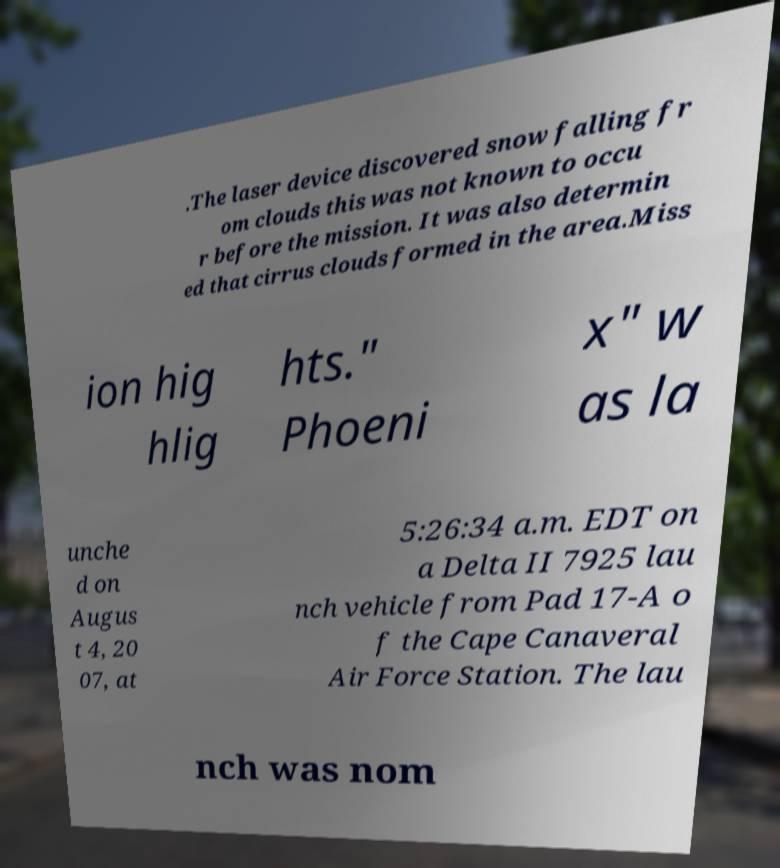Can you accurately transcribe the text from the provided image for me? .The laser device discovered snow falling fr om clouds this was not known to occu r before the mission. It was also determin ed that cirrus clouds formed in the area.Miss ion hig hlig hts." Phoeni x" w as la unche d on Augus t 4, 20 07, at 5:26:34 a.m. EDT on a Delta II 7925 lau nch vehicle from Pad 17-A o f the Cape Canaveral Air Force Station. The lau nch was nom 